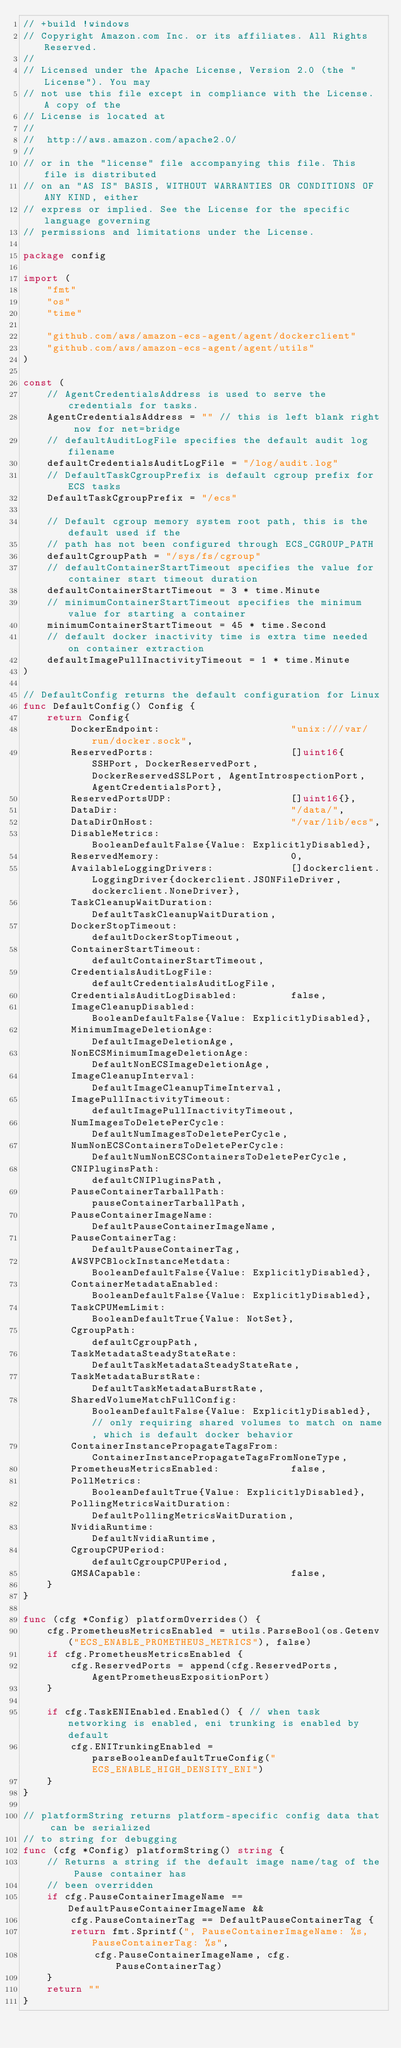<code> <loc_0><loc_0><loc_500><loc_500><_Go_>// +build !windows
// Copyright Amazon.com Inc. or its affiliates. All Rights Reserved.
//
// Licensed under the Apache License, Version 2.0 (the "License"). You may
// not use this file except in compliance with the License. A copy of the
// License is located at
//
//	http://aws.amazon.com/apache2.0/
//
// or in the "license" file accompanying this file. This file is distributed
// on an "AS IS" BASIS, WITHOUT WARRANTIES OR CONDITIONS OF ANY KIND, either
// express or implied. See the License for the specific language governing
// permissions and limitations under the License.

package config

import (
	"fmt"
	"os"
	"time"

	"github.com/aws/amazon-ecs-agent/agent/dockerclient"
	"github.com/aws/amazon-ecs-agent/agent/utils"
)

const (
	// AgentCredentialsAddress is used to serve the credentials for tasks.
	AgentCredentialsAddress = "" // this is left blank right now for net=bridge
	// defaultAuditLogFile specifies the default audit log filename
	defaultCredentialsAuditLogFile = "/log/audit.log"
	// DefaultTaskCgroupPrefix is default cgroup prefix for ECS tasks
	DefaultTaskCgroupPrefix = "/ecs"

	// Default cgroup memory system root path, this is the default used if the
	// path has not been configured through ECS_CGROUP_PATH
	defaultCgroupPath = "/sys/fs/cgroup"
	// defaultContainerStartTimeout specifies the value for container start timeout duration
	defaultContainerStartTimeout = 3 * time.Minute
	// minimumContainerStartTimeout specifies the minimum value for starting a container
	minimumContainerStartTimeout = 45 * time.Second
	// default docker inactivity time is extra time needed on container extraction
	defaultImagePullInactivityTimeout = 1 * time.Minute
)

// DefaultConfig returns the default configuration for Linux
func DefaultConfig() Config {
	return Config{
		DockerEndpoint:                      "unix:///var/run/docker.sock",
		ReservedPorts:                       []uint16{SSHPort, DockerReservedPort, DockerReservedSSLPort, AgentIntrospectionPort, AgentCredentialsPort},
		ReservedPortsUDP:                    []uint16{},
		DataDir:                             "/data/",
		DataDirOnHost:                       "/var/lib/ecs",
		DisableMetrics:                      BooleanDefaultFalse{Value: ExplicitlyDisabled},
		ReservedMemory:                      0,
		AvailableLoggingDrivers:             []dockerclient.LoggingDriver{dockerclient.JSONFileDriver, dockerclient.NoneDriver},
		TaskCleanupWaitDuration:             DefaultTaskCleanupWaitDuration,
		DockerStopTimeout:                   defaultDockerStopTimeout,
		ContainerStartTimeout:               defaultContainerStartTimeout,
		CredentialsAuditLogFile:             defaultCredentialsAuditLogFile,
		CredentialsAuditLogDisabled:         false,
		ImageCleanupDisabled:                BooleanDefaultFalse{Value: ExplicitlyDisabled},
		MinimumImageDeletionAge:             DefaultImageDeletionAge,
		NonECSMinimumImageDeletionAge:       DefaultNonECSImageDeletionAge,
		ImageCleanupInterval:                DefaultImageCleanupTimeInterval,
		ImagePullInactivityTimeout:          defaultImagePullInactivityTimeout,
		NumImagesToDeletePerCycle:           DefaultNumImagesToDeletePerCycle,
		NumNonECSContainersToDeletePerCycle: DefaultNumNonECSContainersToDeletePerCycle,
		CNIPluginsPath:                      defaultCNIPluginsPath,
		PauseContainerTarballPath:           pauseContainerTarballPath,
		PauseContainerImageName:             DefaultPauseContainerImageName,
		PauseContainerTag:                   DefaultPauseContainerTag,
		AWSVPCBlockInstanceMetdata:          BooleanDefaultFalse{Value: ExplicitlyDisabled},
		ContainerMetadataEnabled:            BooleanDefaultFalse{Value: ExplicitlyDisabled},
		TaskCPUMemLimit:                     BooleanDefaultTrue{Value: NotSet},
		CgroupPath:                          defaultCgroupPath,
		TaskMetadataSteadyStateRate:         DefaultTaskMetadataSteadyStateRate,
		TaskMetadataBurstRate:               DefaultTaskMetadataBurstRate,
		SharedVolumeMatchFullConfig:         BooleanDefaultFalse{Value: ExplicitlyDisabled}, // only requiring shared volumes to match on name, which is default docker behavior
		ContainerInstancePropagateTagsFrom:  ContainerInstancePropagateTagsFromNoneType,
		PrometheusMetricsEnabled:            false,
		PollMetrics:                         BooleanDefaultTrue{Value: ExplicitlyDisabled},
		PollingMetricsWaitDuration:          DefaultPollingMetricsWaitDuration,
		NvidiaRuntime:                       DefaultNvidiaRuntime,
		CgroupCPUPeriod:                     defaultCgroupCPUPeriod,
		GMSACapable:                         false,
	}
}

func (cfg *Config) platformOverrides() {
	cfg.PrometheusMetricsEnabled = utils.ParseBool(os.Getenv("ECS_ENABLE_PROMETHEUS_METRICS"), false)
	if cfg.PrometheusMetricsEnabled {
		cfg.ReservedPorts = append(cfg.ReservedPorts, AgentPrometheusExpositionPort)
	}

	if cfg.TaskENIEnabled.Enabled() { // when task networking is enabled, eni trunking is enabled by default
		cfg.ENITrunkingEnabled = parseBooleanDefaultTrueConfig("ECS_ENABLE_HIGH_DENSITY_ENI")
	}
}

// platformString returns platform-specific config data that can be serialized
// to string for debugging
func (cfg *Config) platformString() string {
	// Returns a string if the default image name/tag of the Pause container has
	// been overridden
	if cfg.PauseContainerImageName == DefaultPauseContainerImageName &&
		cfg.PauseContainerTag == DefaultPauseContainerTag {
		return fmt.Sprintf(", PauseContainerImageName: %s, PauseContainerTag: %s",
			cfg.PauseContainerImageName, cfg.PauseContainerTag)
	}
	return ""
}
</code> 